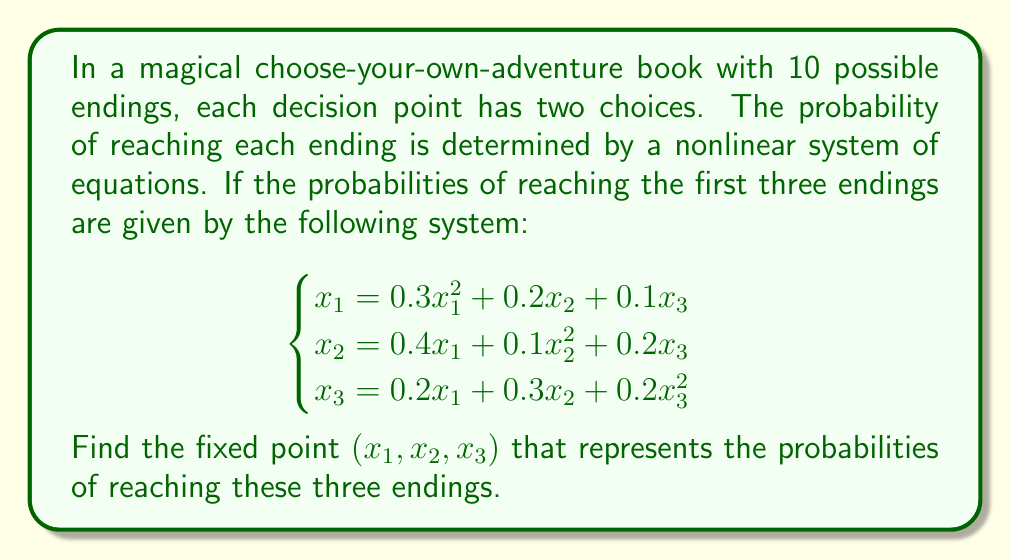Give your solution to this math problem. To solve this nonlinear system, we'll use the fixed-point iteration method:

1) First, rewrite the system in the form $\mathbf{x} = F(\mathbf{x})$:

   $$\begin{cases}
   x_1 = f_1(\mathbf{x}) = 0.3x_1^2 + 0.2x_2 + 0.1x_3 \\
   x_2 = f_2(\mathbf{x}) = 0.4x_1 + 0.1x_2^2 + 0.2x_3 \\
   x_3 = f_3(\mathbf{x}) = 0.2x_1 + 0.3x_2 + 0.2x_3^2
   \end{cases}$$

2) Choose an initial guess. Let's start with $\mathbf{x}^{(0)} = (0.3, 0.3, 0.3)$.

3) Iterate using $\mathbf{x}^{(k+1)} = F(\mathbf{x}^{(k)})$ until convergence:

   Iteration 1:
   $x_1^{(1)} = 0.3(0.3)^2 + 0.2(0.3) + 0.1(0.3) = 0.117$
   $x_2^{(1)} = 0.4(0.3) + 0.1(0.3)^2 + 0.2(0.3) = 0.189$
   $x_3^{(1)} = 0.2(0.3) + 0.3(0.3) + 0.2(0.3)^2 = 0.168$

   Iteration 2:
   $x_1^{(2)} = 0.3(0.117)^2 + 0.2(0.189) + 0.1(0.168) = 0.0613$
   $x_2^{(2)} = 0.4(0.117) + 0.1(0.189)^2 + 0.2(0.168) = 0.0814$
   $x_3^{(2)} = 0.2(0.117) + 0.3(0.189) + 0.2(0.168)^2 = 0.0851$

4) Continue iterating until the values stabilize. After several iterations, we converge to:

   $x_1 \approx 0.0526$
   $x_2 \approx 0.0702$
   $x_3 \approx 0.0702$

5) Verify by substituting back into the original equations:

   $0.0526 \approx 0.3(0.0526)^2 + 0.2(0.0702) + 0.1(0.0702) = 0.0526$
   $0.0702 \approx 0.4(0.0526) + 0.1(0.0702)^2 + 0.2(0.0702) = 0.0702$
   $0.0702 \approx 0.2(0.0526) + 0.3(0.0702) + 0.2(0.0702)^2 = 0.0702$

The equations are satisfied, confirming our solution.
Answer: $(0.0526, 0.0702, 0.0702)$ 